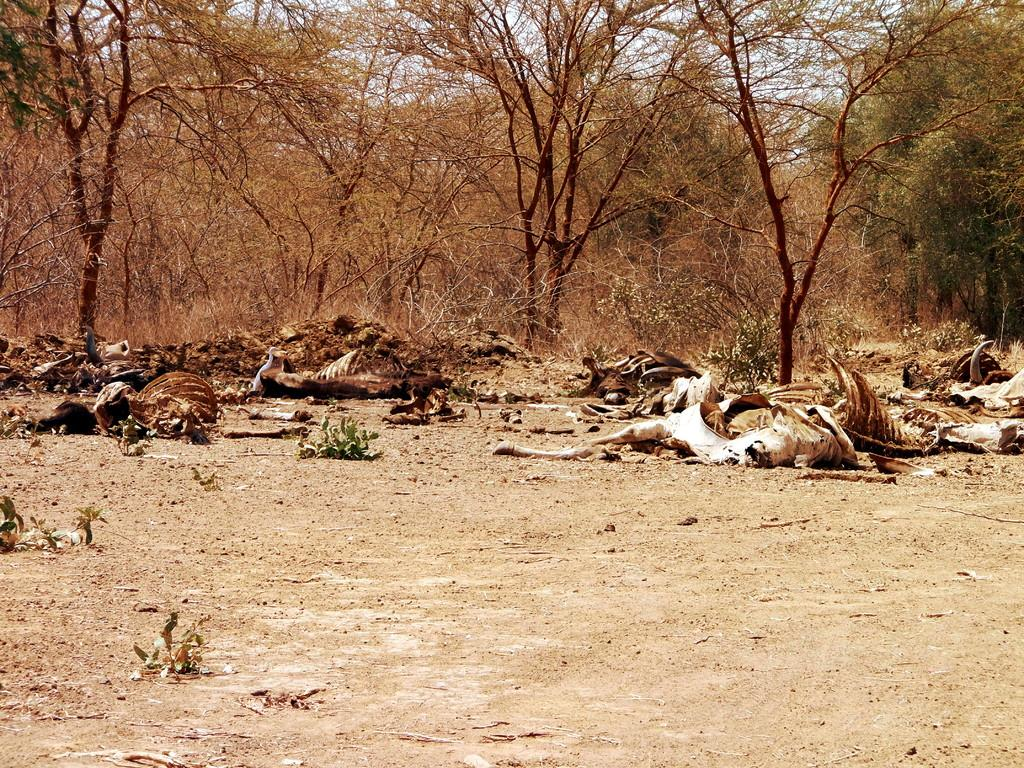What is lying on the ground in the image? There is animal flesh lying on the ground in the image. What type of vegetation can be seen in the image? There are trees and plants in the image. What color is the ink used by the animal in the image? There is no ink or animal using ink present in the image. How does the comb help the animal in the image? There is no comb or animal using a comb present in the image. 